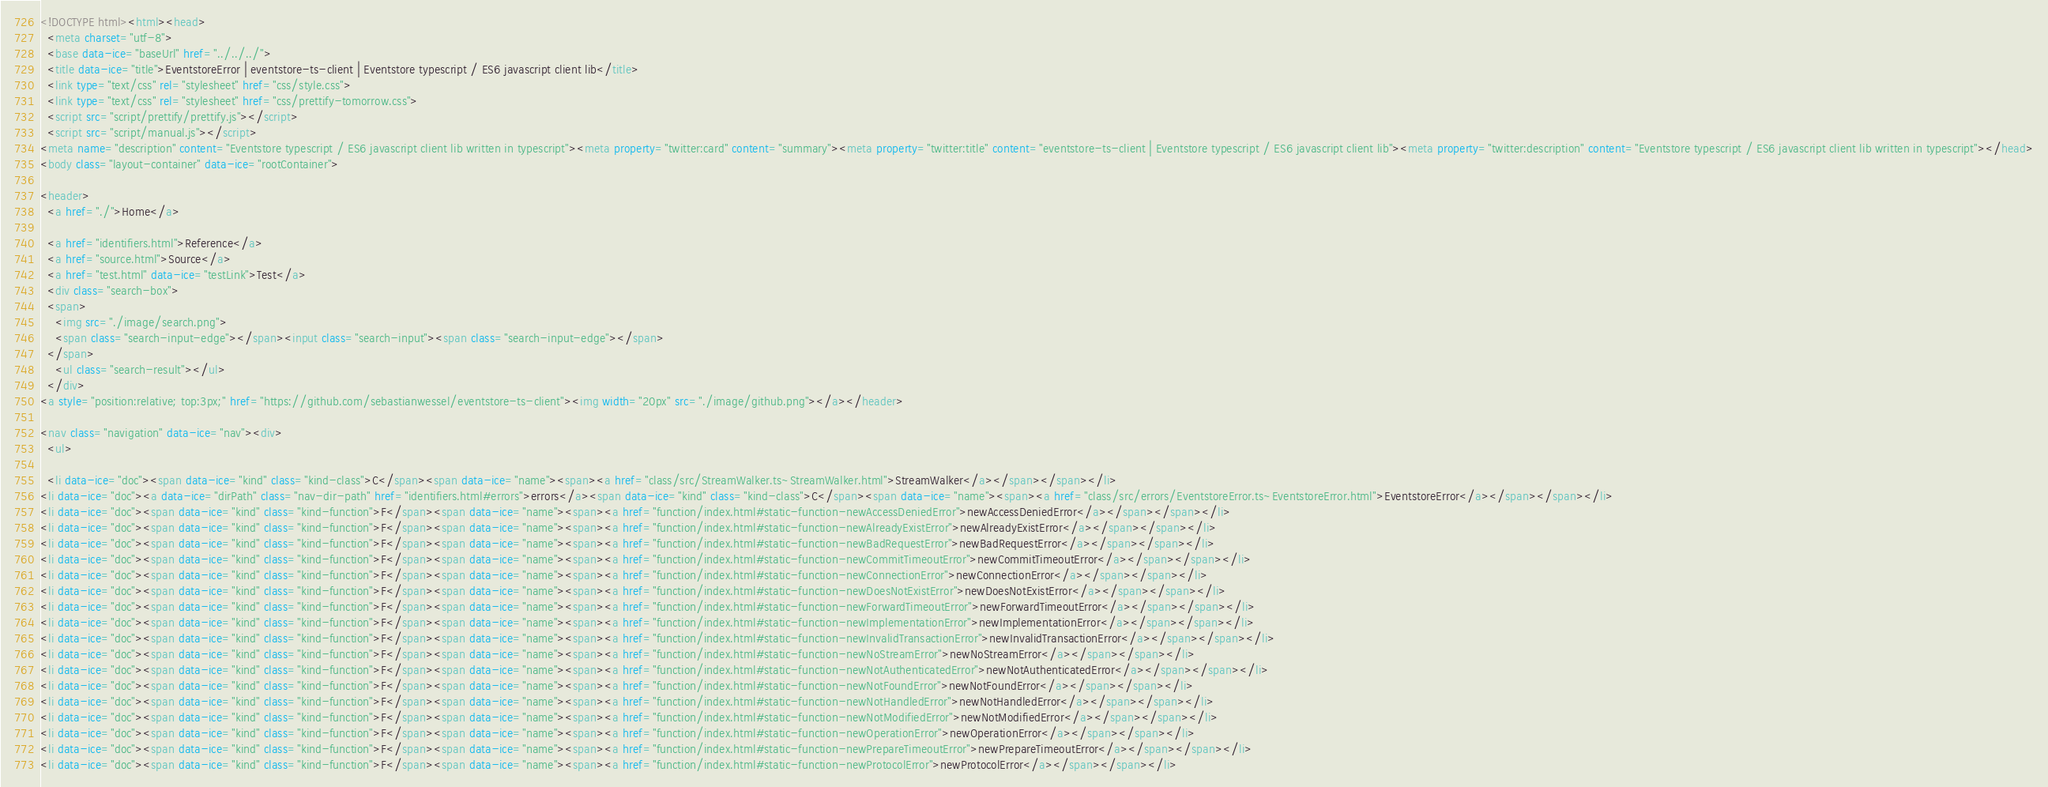Convert code to text. <code><loc_0><loc_0><loc_500><loc_500><_HTML_><!DOCTYPE html><html><head>
  <meta charset="utf-8">
  <base data-ice="baseUrl" href="../../../">
  <title data-ice="title">EventstoreError | eventstore-ts-client | Eventstore typescript / ES6 javascript client lib</title>
  <link type="text/css" rel="stylesheet" href="css/style.css">
  <link type="text/css" rel="stylesheet" href="css/prettify-tomorrow.css">
  <script src="script/prettify/prettify.js"></script>
  <script src="script/manual.js"></script>
<meta name="description" content="Eventstore typescript / ES6 javascript client lib written in typescript"><meta property="twitter:card" content="summary"><meta property="twitter:title" content="eventstore-ts-client | Eventstore typescript / ES6 javascript client lib"><meta property="twitter:description" content="Eventstore typescript / ES6 javascript client lib written in typescript"></head>
<body class="layout-container" data-ice="rootContainer">

<header>
  <a href="./">Home</a>
  
  <a href="identifiers.html">Reference</a>
  <a href="source.html">Source</a>
  <a href="test.html" data-ice="testLink">Test</a>
  <div class="search-box">
  <span>
    <img src="./image/search.png">
    <span class="search-input-edge"></span><input class="search-input"><span class="search-input-edge"></span>
  </span>
    <ul class="search-result"></ul>
  </div>
<a style="position:relative; top:3px;" href="https://github.com/sebastianwessel/eventstore-ts-client"><img width="20px" src="./image/github.png"></a></header>

<nav class="navigation" data-ice="nav"><div>
  <ul>
    
  <li data-ice="doc"><span data-ice="kind" class="kind-class">C</span><span data-ice="name"><span><a href="class/src/StreamWalker.ts~StreamWalker.html">StreamWalker</a></span></span></li>
<li data-ice="doc"><a data-ice="dirPath" class="nav-dir-path" href="identifiers.html#errors">errors</a><span data-ice="kind" class="kind-class">C</span><span data-ice="name"><span><a href="class/src/errors/EventstoreError.ts~EventstoreError.html">EventstoreError</a></span></span></li>
<li data-ice="doc"><span data-ice="kind" class="kind-function">F</span><span data-ice="name"><span><a href="function/index.html#static-function-newAccessDeniedError">newAccessDeniedError</a></span></span></li>
<li data-ice="doc"><span data-ice="kind" class="kind-function">F</span><span data-ice="name"><span><a href="function/index.html#static-function-newAlreadyExistError">newAlreadyExistError</a></span></span></li>
<li data-ice="doc"><span data-ice="kind" class="kind-function">F</span><span data-ice="name"><span><a href="function/index.html#static-function-newBadRequestError">newBadRequestError</a></span></span></li>
<li data-ice="doc"><span data-ice="kind" class="kind-function">F</span><span data-ice="name"><span><a href="function/index.html#static-function-newCommitTimeoutError">newCommitTimeoutError</a></span></span></li>
<li data-ice="doc"><span data-ice="kind" class="kind-function">F</span><span data-ice="name"><span><a href="function/index.html#static-function-newConnectionError">newConnectionError</a></span></span></li>
<li data-ice="doc"><span data-ice="kind" class="kind-function">F</span><span data-ice="name"><span><a href="function/index.html#static-function-newDoesNotExistError">newDoesNotExistError</a></span></span></li>
<li data-ice="doc"><span data-ice="kind" class="kind-function">F</span><span data-ice="name"><span><a href="function/index.html#static-function-newForwardTimeoutError">newForwardTimeoutError</a></span></span></li>
<li data-ice="doc"><span data-ice="kind" class="kind-function">F</span><span data-ice="name"><span><a href="function/index.html#static-function-newImplementationError">newImplementationError</a></span></span></li>
<li data-ice="doc"><span data-ice="kind" class="kind-function">F</span><span data-ice="name"><span><a href="function/index.html#static-function-newInvalidTransactionError">newInvalidTransactionError</a></span></span></li>
<li data-ice="doc"><span data-ice="kind" class="kind-function">F</span><span data-ice="name"><span><a href="function/index.html#static-function-newNoStreamError">newNoStreamError</a></span></span></li>
<li data-ice="doc"><span data-ice="kind" class="kind-function">F</span><span data-ice="name"><span><a href="function/index.html#static-function-newNotAuthenticatedError">newNotAuthenticatedError</a></span></span></li>
<li data-ice="doc"><span data-ice="kind" class="kind-function">F</span><span data-ice="name"><span><a href="function/index.html#static-function-newNotFoundError">newNotFoundError</a></span></span></li>
<li data-ice="doc"><span data-ice="kind" class="kind-function">F</span><span data-ice="name"><span><a href="function/index.html#static-function-newNotHandledError">newNotHandledError</a></span></span></li>
<li data-ice="doc"><span data-ice="kind" class="kind-function">F</span><span data-ice="name"><span><a href="function/index.html#static-function-newNotModifiedError">newNotModifiedError</a></span></span></li>
<li data-ice="doc"><span data-ice="kind" class="kind-function">F</span><span data-ice="name"><span><a href="function/index.html#static-function-newOperationError">newOperationError</a></span></span></li>
<li data-ice="doc"><span data-ice="kind" class="kind-function">F</span><span data-ice="name"><span><a href="function/index.html#static-function-newPrepareTimeoutError">newPrepareTimeoutError</a></span></span></li>
<li data-ice="doc"><span data-ice="kind" class="kind-function">F</span><span data-ice="name"><span><a href="function/index.html#static-function-newProtocolError">newProtocolError</a></span></span></li></code> 